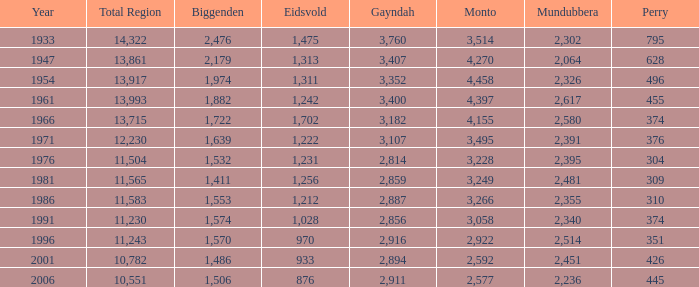In which year does mundubbera have a population less than 2,395 and biggenden less than 1,506? None. 